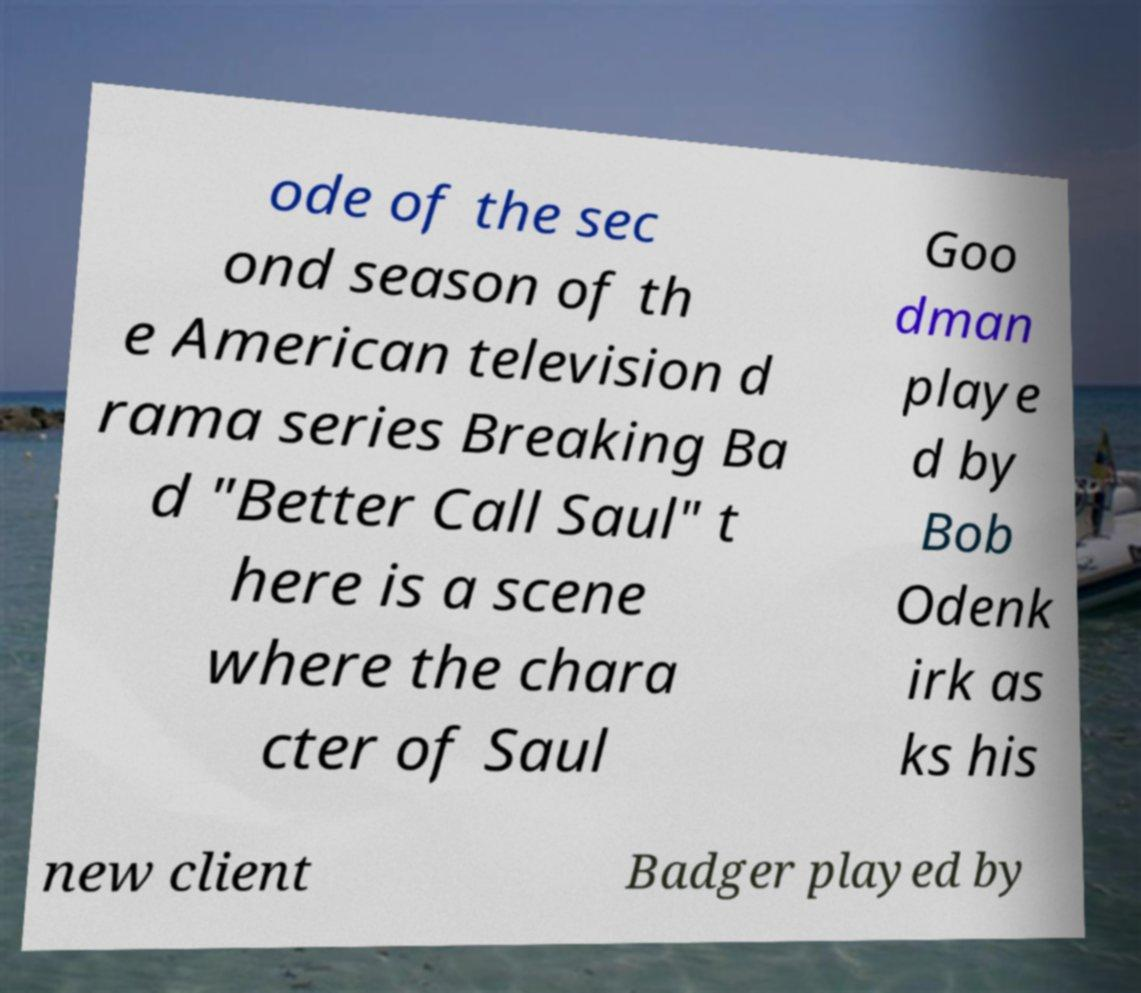Could you assist in decoding the text presented in this image and type it out clearly? ode of the sec ond season of th e American television d rama series Breaking Ba d "Better Call Saul" t here is a scene where the chara cter of Saul Goo dman playe d by Bob Odenk irk as ks his new client Badger played by 